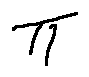<formula> <loc_0><loc_0><loc_500><loc_500>\pi</formula> 